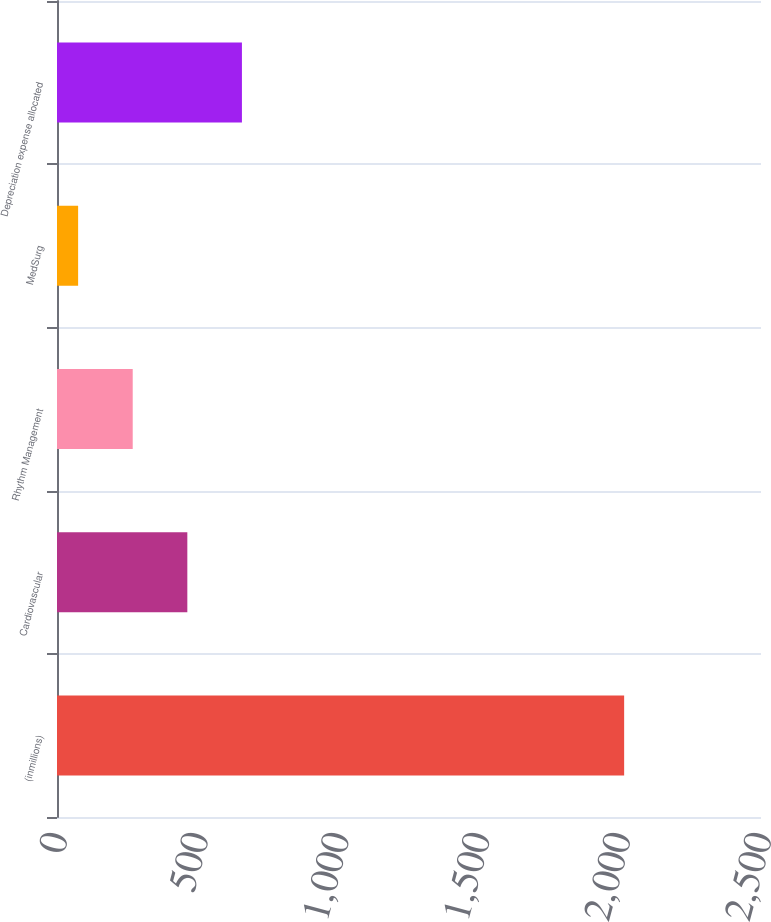Convert chart. <chart><loc_0><loc_0><loc_500><loc_500><bar_chart><fcel>(inmillions)<fcel>Cardiovascular<fcel>Rhythm Management<fcel>MedSurg<fcel>Depreciation expense allocated<nl><fcel>2014<fcel>462.8<fcel>268.9<fcel>75<fcel>656.7<nl></chart> 